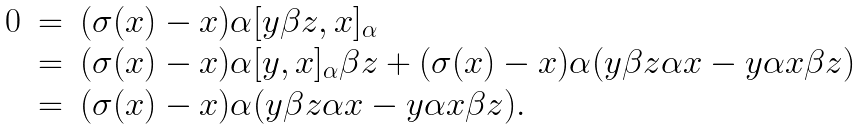Convert formula to latex. <formula><loc_0><loc_0><loc_500><loc_500>\begin{array} { r c l } 0 & = & ( \sigma ( x ) - x ) \alpha [ y \beta z , x ] _ { \alpha } \\ & = & ( \sigma ( x ) - x ) \alpha [ y , x ] _ { \alpha } \beta z + ( \sigma ( x ) - x ) \alpha ( y \beta z \alpha x - y \alpha x \beta z ) \\ & = & ( \sigma ( x ) - x ) \alpha ( y \beta z \alpha x - y \alpha x \beta z ) . \end{array}</formula> 